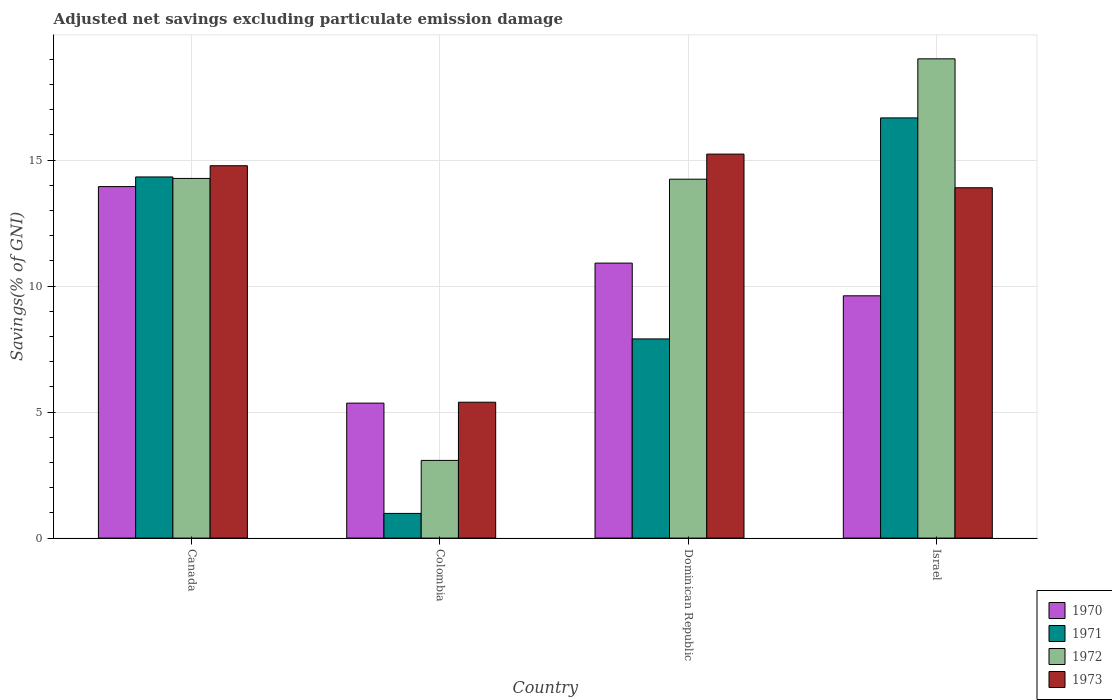How many bars are there on the 1st tick from the left?
Your answer should be very brief. 4. What is the adjusted net savings in 1970 in Dominican Republic?
Provide a succinct answer. 10.91. Across all countries, what is the maximum adjusted net savings in 1973?
Your response must be concise. 15.24. Across all countries, what is the minimum adjusted net savings in 1970?
Keep it short and to the point. 5.36. In which country was the adjusted net savings in 1971 minimum?
Make the answer very short. Colombia. What is the total adjusted net savings in 1972 in the graph?
Offer a very short reply. 50.62. What is the difference between the adjusted net savings in 1971 in Canada and that in Israel?
Ensure brevity in your answer.  -2.34. What is the difference between the adjusted net savings in 1971 in Dominican Republic and the adjusted net savings in 1973 in Canada?
Offer a terse response. -6.87. What is the average adjusted net savings in 1973 per country?
Make the answer very short. 12.33. What is the difference between the adjusted net savings of/in 1973 and adjusted net savings of/in 1972 in Canada?
Your answer should be compact. 0.5. What is the ratio of the adjusted net savings in 1972 in Canada to that in Israel?
Your answer should be compact. 0.75. Is the difference between the adjusted net savings in 1973 in Dominican Republic and Israel greater than the difference between the adjusted net savings in 1972 in Dominican Republic and Israel?
Give a very brief answer. Yes. What is the difference between the highest and the second highest adjusted net savings in 1971?
Keep it short and to the point. 2.34. What is the difference between the highest and the lowest adjusted net savings in 1973?
Offer a very short reply. 9.85. In how many countries, is the adjusted net savings in 1971 greater than the average adjusted net savings in 1971 taken over all countries?
Ensure brevity in your answer.  2. Is it the case that in every country, the sum of the adjusted net savings in 1972 and adjusted net savings in 1970 is greater than the sum of adjusted net savings in 1971 and adjusted net savings in 1973?
Your answer should be very brief. No. What does the 1st bar from the left in Israel represents?
Your answer should be compact. 1970. Is it the case that in every country, the sum of the adjusted net savings in 1972 and adjusted net savings in 1973 is greater than the adjusted net savings in 1970?
Make the answer very short. Yes. Does the graph contain grids?
Keep it short and to the point. Yes. Where does the legend appear in the graph?
Provide a succinct answer. Bottom right. How are the legend labels stacked?
Provide a short and direct response. Vertical. What is the title of the graph?
Keep it short and to the point. Adjusted net savings excluding particulate emission damage. Does "1991" appear as one of the legend labels in the graph?
Offer a terse response. No. What is the label or title of the X-axis?
Offer a very short reply. Country. What is the label or title of the Y-axis?
Offer a very short reply. Savings(% of GNI). What is the Savings(% of GNI) of 1970 in Canada?
Ensure brevity in your answer.  13.95. What is the Savings(% of GNI) of 1971 in Canada?
Offer a very short reply. 14.33. What is the Savings(% of GNI) in 1972 in Canada?
Your answer should be very brief. 14.27. What is the Savings(% of GNI) in 1973 in Canada?
Offer a terse response. 14.78. What is the Savings(% of GNI) of 1970 in Colombia?
Provide a short and direct response. 5.36. What is the Savings(% of GNI) of 1971 in Colombia?
Give a very brief answer. 0.98. What is the Savings(% of GNI) in 1972 in Colombia?
Your answer should be compact. 3.08. What is the Savings(% of GNI) in 1973 in Colombia?
Offer a terse response. 5.39. What is the Savings(% of GNI) in 1970 in Dominican Republic?
Give a very brief answer. 10.91. What is the Savings(% of GNI) of 1971 in Dominican Republic?
Ensure brevity in your answer.  7.9. What is the Savings(% of GNI) in 1972 in Dominican Republic?
Ensure brevity in your answer.  14.24. What is the Savings(% of GNI) of 1973 in Dominican Republic?
Offer a terse response. 15.24. What is the Savings(% of GNI) of 1970 in Israel?
Provide a short and direct response. 9.61. What is the Savings(% of GNI) of 1971 in Israel?
Provide a short and direct response. 16.67. What is the Savings(% of GNI) of 1972 in Israel?
Your answer should be compact. 19.02. What is the Savings(% of GNI) in 1973 in Israel?
Offer a terse response. 13.9. Across all countries, what is the maximum Savings(% of GNI) in 1970?
Provide a succinct answer. 13.95. Across all countries, what is the maximum Savings(% of GNI) of 1971?
Ensure brevity in your answer.  16.67. Across all countries, what is the maximum Savings(% of GNI) in 1972?
Provide a short and direct response. 19.02. Across all countries, what is the maximum Savings(% of GNI) in 1973?
Your answer should be very brief. 15.24. Across all countries, what is the minimum Savings(% of GNI) of 1970?
Offer a very short reply. 5.36. Across all countries, what is the minimum Savings(% of GNI) in 1971?
Make the answer very short. 0.98. Across all countries, what is the minimum Savings(% of GNI) in 1972?
Your response must be concise. 3.08. Across all countries, what is the minimum Savings(% of GNI) in 1973?
Provide a short and direct response. 5.39. What is the total Savings(% of GNI) of 1970 in the graph?
Provide a short and direct response. 39.83. What is the total Savings(% of GNI) of 1971 in the graph?
Your answer should be compact. 39.89. What is the total Savings(% of GNI) of 1972 in the graph?
Your answer should be compact. 50.62. What is the total Savings(% of GNI) in 1973 in the graph?
Provide a short and direct response. 49.31. What is the difference between the Savings(% of GNI) in 1970 in Canada and that in Colombia?
Offer a terse response. 8.59. What is the difference between the Savings(% of GNI) of 1971 in Canada and that in Colombia?
Offer a terse response. 13.35. What is the difference between the Savings(% of GNI) in 1972 in Canada and that in Colombia?
Offer a terse response. 11.19. What is the difference between the Savings(% of GNI) in 1973 in Canada and that in Colombia?
Make the answer very short. 9.38. What is the difference between the Savings(% of GNI) in 1970 in Canada and that in Dominican Republic?
Provide a succinct answer. 3.04. What is the difference between the Savings(% of GNI) of 1971 in Canada and that in Dominican Republic?
Make the answer very short. 6.43. What is the difference between the Savings(% of GNI) of 1972 in Canada and that in Dominican Republic?
Provide a succinct answer. 0.03. What is the difference between the Savings(% of GNI) of 1973 in Canada and that in Dominican Republic?
Ensure brevity in your answer.  -0.46. What is the difference between the Savings(% of GNI) in 1970 in Canada and that in Israel?
Give a very brief answer. 4.33. What is the difference between the Savings(% of GNI) of 1971 in Canada and that in Israel?
Provide a succinct answer. -2.34. What is the difference between the Savings(% of GNI) in 1972 in Canada and that in Israel?
Provide a succinct answer. -4.75. What is the difference between the Savings(% of GNI) in 1973 in Canada and that in Israel?
Your answer should be very brief. 0.87. What is the difference between the Savings(% of GNI) in 1970 in Colombia and that in Dominican Republic?
Your answer should be very brief. -5.56. What is the difference between the Savings(% of GNI) of 1971 in Colombia and that in Dominican Republic?
Provide a short and direct response. -6.92. What is the difference between the Savings(% of GNI) in 1972 in Colombia and that in Dominican Republic?
Make the answer very short. -11.16. What is the difference between the Savings(% of GNI) of 1973 in Colombia and that in Dominican Republic?
Your response must be concise. -9.85. What is the difference between the Savings(% of GNI) in 1970 in Colombia and that in Israel?
Give a very brief answer. -4.26. What is the difference between the Savings(% of GNI) in 1971 in Colombia and that in Israel?
Keep it short and to the point. -15.7. What is the difference between the Savings(% of GNI) of 1972 in Colombia and that in Israel?
Make the answer very short. -15.94. What is the difference between the Savings(% of GNI) of 1973 in Colombia and that in Israel?
Keep it short and to the point. -8.51. What is the difference between the Savings(% of GNI) in 1970 in Dominican Republic and that in Israel?
Your answer should be very brief. 1.3. What is the difference between the Savings(% of GNI) in 1971 in Dominican Republic and that in Israel?
Ensure brevity in your answer.  -8.77. What is the difference between the Savings(% of GNI) in 1972 in Dominican Republic and that in Israel?
Your response must be concise. -4.78. What is the difference between the Savings(% of GNI) in 1973 in Dominican Republic and that in Israel?
Your response must be concise. 1.34. What is the difference between the Savings(% of GNI) of 1970 in Canada and the Savings(% of GNI) of 1971 in Colombia?
Make the answer very short. 12.97. What is the difference between the Savings(% of GNI) in 1970 in Canada and the Savings(% of GNI) in 1972 in Colombia?
Your answer should be compact. 10.87. What is the difference between the Savings(% of GNI) of 1970 in Canada and the Savings(% of GNI) of 1973 in Colombia?
Offer a very short reply. 8.56. What is the difference between the Savings(% of GNI) in 1971 in Canada and the Savings(% of GNI) in 1972 in Colombia?
Your answer should be compact. 11.25. What is the difference between the Savings(% of GNI) in 1971 in Canada and the Savings(% of GNI) in 1973 in Colombia?
Keep it short and to the point. 8.94. What is the difference between the Savings(% of GNI) of 1972 in Canada and the Savings(% of GNI) of 1973 in Colombia?
Make the answer very short. 8.88. What is the difference between the Savings(% of GNI) in 1970 in Canada and the Savings(% of GNI) in 1971 in Dominican Republic?
Your answer should be compact. 6.05. What is the difference between the Savings(% of GNI) of 1970 in Canada and the Savings(% of GNI) of 1972 in Dominican Republic?
Your response must be concise. -0.29. What is the difference between the Savings(% of GNI) of 1970 in Canada and the Savings(% of GNI) of 1973 in Dominican Republic?
Your answer should be compact. -1.29. What is the difference between the Savings(% of GNI) in 1971 in Canada and the Savings(% of GNI) in 1972 in Dominican Republic?
Offer a very short reply. 0.09. What is the difference between the Savings(% of GNI) of 1971 in Canada and the Savings(% of GNI) of 1973 in Dominican Republic?
Offer a very short reply. -0.91. What is the difference between the Savings(% of GNI) of 1972 in Canada and the Savings(% of GNI) of 1973 in Dominican Republic?
Your answer should be very brief. -0.97. What is the difference between the Savings(% of GNI) of 1970 in Canada and the Savings(% of GNI) of 1971 in Israel?
Provide a succinct answer. -2.73. What is the difference between the Savings(% of GNI) in 1970 in Canada and the Savings(% of GNI) in 1972 in Israel?
Offer a terse response. -5.07. What is the difference between the Savings(% of GNI) of 1970 in Canada and the Savings(% of GNI) of 1973 in Israel?
Offer a very short reply. 0.05. What is the difference between the Savings(% of GNI) of 1971 in Canada and the Savings(% of GNI) of 1972 in Israel?
Your answer should be very brief. -4.69. What is the difference between the Savings(% of GNI) of 1971 in Canada and the Savings(% of GNI) of 1973 in Israel?
Give a very brief answer. 0.43. What is the difference between the Savings(% of GNI) in 1972 in Canada and the Savings(% of GNI) in 1973 in Israel?
Offer a very short reply. 0.37. What is the difference between the Savings(% of GNI) in 1970 in Colombia and the Savings(% of GNI) in 1971 in Dominican Republic?
Provide a short and direct response. -2.55. What is the difference between the Savings(% of GNI) in 1970 in Colombia and the Savings(% of GNI) in 1972 in Dominican Republic?
Make the answer very short. -8.89. What is the difference between the Savings(% of GNI) in 1970 in Colombia and the Savings(% of GNI) in 1973 in Dominican Republic?
Provide a short and direct response. -9.88. What is the difference between the Savings(% of GNI) in 1971 in Colombia and the Savings(% of GNI) in 1972 in Dominican Republic?
Provide a short and direct response. -13.26. What is the difference between the Savings(% of GNI) of 1971 in Colombia and the Savings(% of GNI) of 1973 in Dominican Republic?
Give a very brief answer. -14.26. What is the difference between the Savings(% of GNI) in 1972 in Colombia and the Savings(% of GNI) in 1973 in Dominican Republic?
Your response must be concise. -12.15. What is the difference between the Savings(% of GNI) in 1970 in Colombia and the Savings(% of GNI) in 1971 in Israel?
Offer a very short reply. -11.32. What is the difference between the Savings(% of GNI) in 1970 in Colombia and the Savings(% of GNI) in 1972 in Israel?
Offer a terse response. -13.66. What is the difference between the Savings(% of GNI) in 1970 in Colombia and the Savings(% of GNI) in 1973 in Israel?
Give a very brief answer. -8.55. What is the difference between the Savings(% of GNI) of 1971 in Colombia and the Savings(% of GNI) of 1972 in Israel?
Give a very brief answer. -18.04. What is the difference between the Savings(% of GNI) of 1971 in Colombia and the Savings(% of GNI) of 1973 in Israel?
Provide a short and direct response. -12.92. What is the difference between the Savings(% of GNI) of 1972 in Colombia and the Savings(% of GNI) of 1973 in Israel?
Your answer should be compact. -10.82. What is the difference between the Savings(% of GNI) in 1970 in Dominican Republic and the Savings(% of GNI) in 1971 in Israel?
Make the answer very short. -5.76. What is the difference between the Savings(% of GNI) of 1970 in Dominican Republic and the Savings(% of GNI) of 1972 in Israel?
Your response must be concise. -8.11. What is the difference between the Savings(% of GNI) in 1970 in Dominican Republic and the Savings(% of GNI) in 1973 in Israel?
Ensure brevity in your answer.  -2.99. What is the difference between the Savings(% of GNI) in 1971 in Dominican Republic and the Savings(% of GNI) in 1972 in Israel?
Your answer should be compact. -11.11. What is the difference between the Savings(% of GNI) of 1971 in Dominican Republic and the Savings(% of GNI) of 1973 in Israel?
Provide a succinct answer. -6. What is the difference between the Savings(% of GNI) of 1972 in Dominican Republic and the Savings(% of GNI) of 1973 in Israel?
Provide a short and direct response. 0.34. What is the average Savings(% of GNI) of 1970 per country?
Offer a terse response. 9.96. What is the average Savings(% of GNI) in 1971 per country?
Provide a succinct answer. 9.97. What is the average Savings(% of GNI) of 1972 per country?
Provide a succinct answer. 12.65. What is the average Savings(% of GNI) in 1973 per country?
Your answer should be compact. 12.33. What is the difference between the Savings(% of GNI) of 1970 and Savings(% of GNI) of 1971 in Canada?
Provide a short and direct response. -0.38. What is the difference between the Savings(% of GNI) of 1970 and Savings(% of GNI) of 1972 in Canada?
Give a very brief answer. -0.32. What is the difference between the Savings(% of GNI) of 1970 and Savings(% of GNI) of 1973 in Canada?
Your answer should be compact. -0.83. What is the difference between the Savings(% of GNI) of 1971 and Savings(% of GNI) of 1972 in Canada?
Make the answer very short. 0.06. What is the difference between the Savings(% of GNI) in 1971 and Savings(% of GNI) in 1973 in Canada?
Make the answer very short. -0.45. What is the difference between the Savings(% of GNI) of 1972 and Savings(% of GNI) of 1973 in Canada?
Your response must be concise. -0.5. What is the difference between the Savings(% of GNI) in 1970 and Savings(% of GNI) in 1971 in Colombia?
Offer a terse response. 4.38. What is the difference between the Savings(% of GNI) in 1970 and Savings(% of GNI) in 1972 in Colombia?
Offer a very short reply. 2.27. What is the difference between the Savings(% of GNI) in 1970 and Savings(% of GNI) in 1973 in Colombia?
Provide a short and direct response. -0.04. What is the difference between the Savings(% of GNI) of 1971 and Savings(% of GNI) of 1972 in Colombia?
Provide a short and direct response. -2.1. What is the difference between the Savings(% of GNI) in 1971 and Savings(% of GNI) in 1973 in Colombia?
Provide a short and direct response. -4.41. What is the difference between the Savings(% of GNI) in 1972 and Savings(% of GNI) in 1973 in Colombia?
Give a very brief answer. -2.31. What is the difference between the Savings(% of GNI) in 1970 and Savings(% of GNI) in 1971 in Dominican Republic?
Give a very brief answer. 3.01. What is the difference between the Savings(% of GNI) in 1970 and Savings(% of GNI) in 1972 in Dominican Republic?
Keep it short and to the point. -3.33. What is the difference between the Savings(% of GNI) of 1970 and Savings(% of GNI) of 1973 in Dominican Republic?
Offer a terse response. -4.33. What is the difference between the Savings(% of GNI) in 1971 and Savings(% of GNI) in 1972 in Dominican Republic?
Provide a succinct answer. -6.34. What is the difference between the Savings(% of GNI) of 1971 and Savings(% of GNI) of 1973 in Dominican Republic?
Offer a terse response. -7.33. What is the difference between the Savings(% of GNI) of 1972 and Savings(% of GNI) of 1973 in Dominican Republic?
Keep it short and to the point. -1. What is the difference between the Savings(% of GNI) in 1970 and Savings(% of GNI) in 1971 in Israel?
Offer a terse response. -7.06. What is the difference between the Savings(% of GNI) of 1970 and Savings(% of GNI) of 1972 in Israel?
Make the answer very short. -9.4. What is the difference between the Savings(% of GNI) of 1970 and Savings(% of GNI) of 1973 in Israel?
Give a very brief answer. -4.29. What is the difference between the Savings(% of GNI) of 1971 and Savings(% of GNI) of 1972 in Israel?
Provide a succinct answer. -2.34. What is the difference between the Savings(% of GNI) in 1971 and Savings(% of GNI) in 1973 in Israel?
Make the answer very short. 2.77. What is the difference between the Savings(% of GNI) of 1972 and Savings(% of GNI) of 1973 in Israel?
Your response must be concise. 5.12. What is the ratio of the Savings(% of GNI) in 1970 in Canada to that in Colombia?
Ensure brevity in your answer.  2.6. What is the ratio of the Savings(% of GNI) in 1971 in Canada to that in Colombia?
Offer a very short reply. 14.64. What is the ratio of the Savings(% of GNI) in 1972 in Canada to that in Colombia?
Make the answer very short. 4.63. What is the ratio of the Savings(% of GNI) in 1973 in Canada to that in Colombia?
Keep it short and to the point. 2.74. What is the ratio of the Savings(% of GNI) of 1970 in Canada to that in Dominican Republic?
Provide a succinct answer. 1.28. What is the ratio of the Savings(% of GNI) in 1971 in Canada to that in Dominican Republic?
Make the answer very short. 1.81. What is the ratio of the Savings(% of GNI) in 1972 in Canada to that in Dominican Republic?
Offer a very short reply. 1. What is the ratio of the Savings(% of GNI) in 1973 in Canada to that in Dominican Republic?
Ensure brevity in your answer.  0.97. What is the ratio of the Savings(% of GNI) in 1970 in Canada to that in Israel?
Make the answer very short. 1.45. What is the ratio of the Savings(% of GNI) of 1971 in Canada to that in Israel?
Ensure brevity in your answer.  0.86. What is the ratio of the Savings(% of GNI) of 1972 in Canada to that in Israel?
Your answer should be compact. 0.75. What is the ratio of the Savings(% of GNI) in 1973 in Canada to that in Israel?
Your answer should be compact. 1.06. What is the ratio of the Savings(% of GNI) in 1970 in Colombia to that in Dominican Republic?
Your answer should be compact. 0.49. What is the ratio of the Savings(% of GNI) in 1971 in Colombia to that in Dominican Republic?
Your answer should be very brief. 0.12. What is the ratio of the Savings(% of GNI) in 1972 in Colombia to that in Dominican Republic?
Your response must be concise. 0.22. What is the ratio of the Savings(% of GNI) in 1973 in Colombia to that in Dominican Republic?
Keep it short and to the point. 0.35. What is the ratio of the Savings(% of GNI) of 1970 in Colombia to that in Israel?
Offer a very short reply. 0.56. What is the ratio of the Savings(% of GNI) in 1971 in Colombia to that in Israel?
Offer a very short reply. 0.06. What is the ratio of the Savings(% of GNI) of 1972 in Colombia to that in Israel?
Ensure brevity in your answer.  0.16. What is the ratio of the Savings(% of GNI) of 1973 in Colombia to that in Israel?
Your answer should be compact. 0.39. What is the ratio of the Savings(% of GNI) in 1970 in Dominican Republic to that in Israel?
Your response must be concise. 1.14. What is the ratio of the Savings(% of GNI) of 1971 in Dominican Republic to that in Israel?
Your answer should be compact. 0.47. What is the ratio of the Savings(% of GNI) of 1972 in Dominican Republic to that in Israel?
Offer a terse response. 0.75. What is the ratio of the Savings(% of GNI) in 1973 in Dominican Republic to that in Israel?
Provide a short and direct response. 1.1. What is the difference between the highest and the second highest Savings(% of GNI) in 1970?
Provide a succinct answer. 3.04. What is the difference between the highest and the second highest Savings(% of GNI) in 1971?
Provide a succinct answer. 2.34. What is the difference between the highest and the second highest Savings(% of GNI) in 1972?
Offer a terse response. 4.75. What is the difference between the highest and the second highest Savings(% of GNI) of 1973?
Offer a very short reply. 0.46. What is the difference between the highest and the lowest Savings(% of GNI) of 1970?
Provide a short and direct response. 8.59. What is the difference between the highest and the lowest Savings(% of GNI) of 1971?
Provide a short and direct response. 15.7. What is the difference between the highest and the lowest Savings(% of GNI) of 1972?
Ensure brevity in your answer.  15.94. What is the difference between the highest and the lowest Savings(% of GNI) of 1973?
Give a very brief answer. 9.85. 